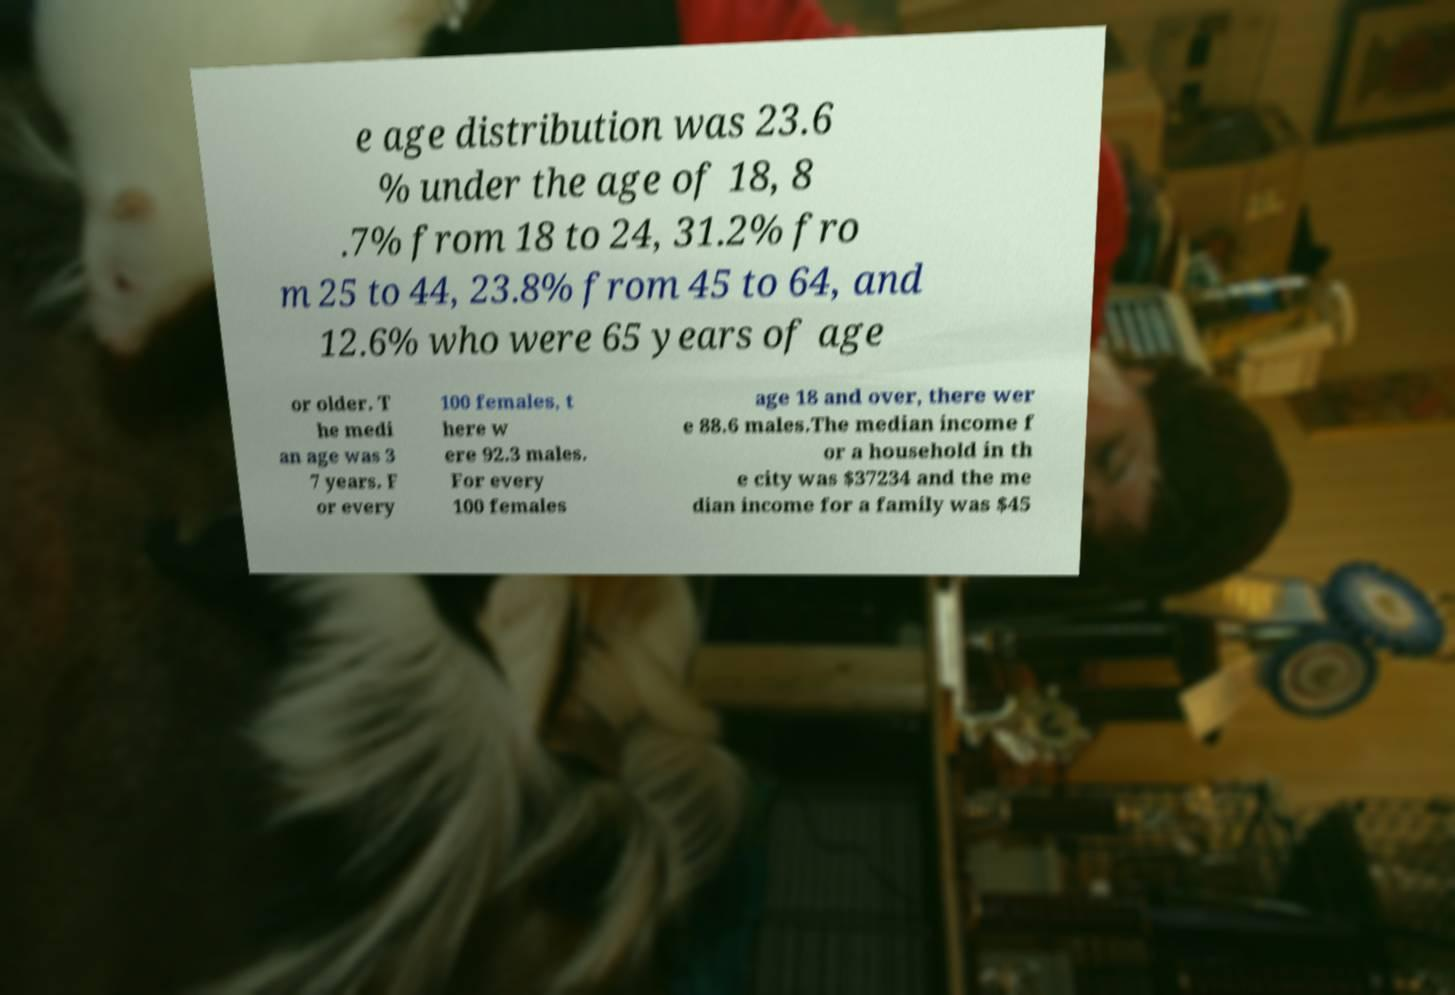Please identify and transcribe the text found in this image. e age distribution was 23.6 % under the age of 18, 8 .7% from 18 to 24, 31.2% fro m 25 to 44, 23.8% from 45 to 64, and 12.6% who were 65 years of age or older. T he medi an age was 3 7 years. F or every 100 females, t here w ere 92.3 males. For every 100 females age 18 and over, there wer e 88.6 males.The median income f or a household in th e city was $37234 and the me dian income for a family was $45 